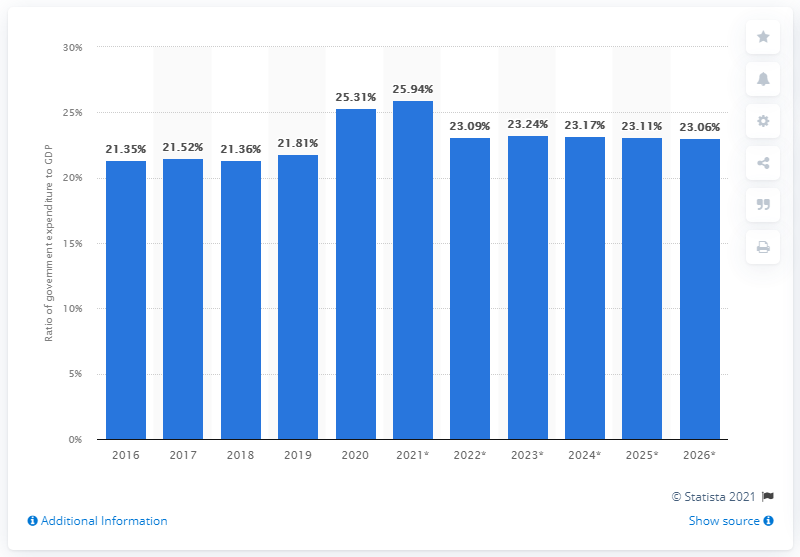Draw attention to some important aspects in this diagram. In 2020, government expenditure accounted for 25.31% of Thailand's Gross Domestic Product (GDP). 